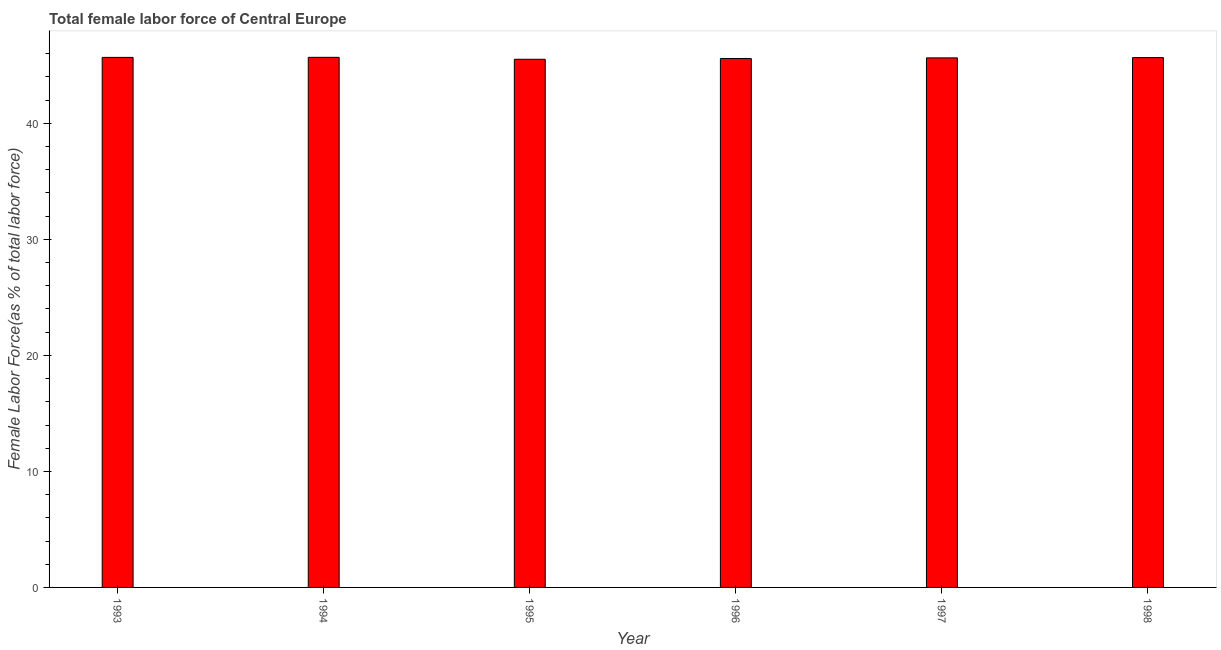Does the graph contain any zero values?
Give a very brief answer. No. Does the graph contain grids?
Make the answer very short. No. What is the title of the graph?
Your response must be concise. Total female labor force of Central Europe. What is the label or title of the X-axis?
Give a very brief answer. Year. What is the label or title of the Y-axis?
Your answer should be compact. Female Labor Force(as % of total labor force). What is the total female labor force in 1994?
Offer a very short reply. 45.69. Across all years, what is the maximum total female labor force?
Offer a very short reply. 45.69. Across all years, what is the minimum total female labor force?
Make the answer very short. 45.53. What is the sum of the total female labor force?
Offer a terse response. 273.82. What is the difference between the total female labor force in 1994 and 1996?
Offer a very short reply. 0.1. What is the average total female labor force per year?
Your answer should be very brief. 45.64. What is the median total female labor force?
Keep it short and to the point. 45.66. In how many years, is the total female labor force greater than 34 %?
Offer a very short reply. 6. What is the ratio of the total female labor force in 1997 to that in 1998?
Ensure brevity in your answer.  1. Is the total female labor force in 1995 less than that in 1996?
Offer a very short reply. Yes. Is the difference between the total female labor force in 1996 and 1997 greater than the difference between any two years?
Your answer should be compact. No. What is the difference between the highest and the second highest total female labor force?
Offer a terse response. 0.01. Is the sum of the total female labor force in 1995 and 1997 greater than the maximum total female labor force across all years?
Make the answer very short. Yes. What is the difference between the highest and the lowest total female labor force?
Your response must be concise. 0.17. How many bars are there?
Make the answer very short. 6. Are all the bars in the graph horizontal?
Offer a terse response. No. How many years are there in the graph?
Ensure brevity in your answer.  6. What is the difference between two consecutive major ticks on the Y-axis?
Offer a very short reply. 10. Are the values on the major ticks of Y-axis written in scientific E-notation?
Your response must be concise. No. What is the Female Labor Force(as % of total labor force) of 1993?
Provide a short and direct response. 45.69. What is the Female Labor Force(as % of total labor force) of 1994?
Provide a short and direct response. 45.69. What is the Female Labor Force(as % of total labor force) of 1995?
Provide a short and direct response. 45.53. What is the Female Labor Force(as % of total labor force) in 1996?
Your answer should be compact. 45.59. What is the Female Labor Force(as % of total labor force) in 1997?
Keep it short and to the point. 45.65. What is the Female Labor Force(as % of total labor force) in 1998?
Offer a terse response. 45.67. What is the difference between the Female Labor Force(as % of total labor force) in 1993 and 1994?
Your answer should be very brief. -0.01. What is the difference between the Female Labor Force(as % of total labor force) in 1993 and 1995?
Your answer should be very brief. 0.16. What is the difference between the Female Labor Force(as % of total labor force) in 1993 and 1996?
Keep it short and to the point. 0.09. What is the difference between the Female Labor Force(as % of total labor force) in 1993 and 1997?
Make the answer very short. 0.04. What is the difference between the Female Labor Force(as % of total labor force) in 1993 and 1998?
Your response must be concise. 0.02. What is the difference between the Female Labor Force(as % of total labor force) in 1994 and 1995?
Your response must be concise. 0.17. What is the difference between the Female Labor Force(as % of total labor force) in 1994 and 1996?
Ensure brevity in your answer.  0.1. What is the difference between the Female Labor Force(as % of total labor force) in 1994 and 1997?
Offer a very short reply. 0.05. What is the difference between the Female Labor Force(as % of total labor force) in 1994 and 1998?
Your response must be concise. 0.02. What is the difference between the Female Labor Force(as % of total labor force) in 1995 and 1996?
Provide a succinct answer. -0.07. What is the difference between the Female Labor Force(as % of total labor force) in 1995 and 1997?
Your answer should be very brief. -0.12. What is the difference between the Female Labor Force(as % of total labor force) in 1995 and 1998?
Ensure brevity in your answer.  -0.14. What is the difference between the Female Labor Force(as % of total labor force) in 1996 and 1997?
Your answer should be compact. -0.05. What is the difference between the Female Labor Force(as % of total labor force) in 1996 and 1998?
Offer a terse response. -0.08. What is the difference between the Female Labor Force(as % of total labor force) in 1997 and 1998?
Provide a short and direct response. -0.02. What is the ratio of the Female Labor Force(as % of total labor force) in 1993 to that in 1994?
Your answer should be very brief. 1. What is the ratio of the Female Labor Force(as % of total labor force) in 1993 to that in 1996?
Keep it short and to the point. 1. What is the ratio of the Female Labor Force(as % of total labor force) in 1993 to that in 1997?
Offer a terse response. 1. What is the ratio of the Female Labor Force(as % of total labor force) in 1994 to that in 1996?
Offer a terse response. 1. What is the ratio of the Female Labor Force(as % of total labor force) in 1994 to that in 1997?
Provide a succinct answer. 1. What is the ratio of the Female Labor Force(as % of total labor force) in 1995 to that in 1997?
Offer a very short reply. 1. What is the ratio of the Female Labor Force(as % of total labor force) in 1996 to that in 1997?
Your answer should be compact. 1. 